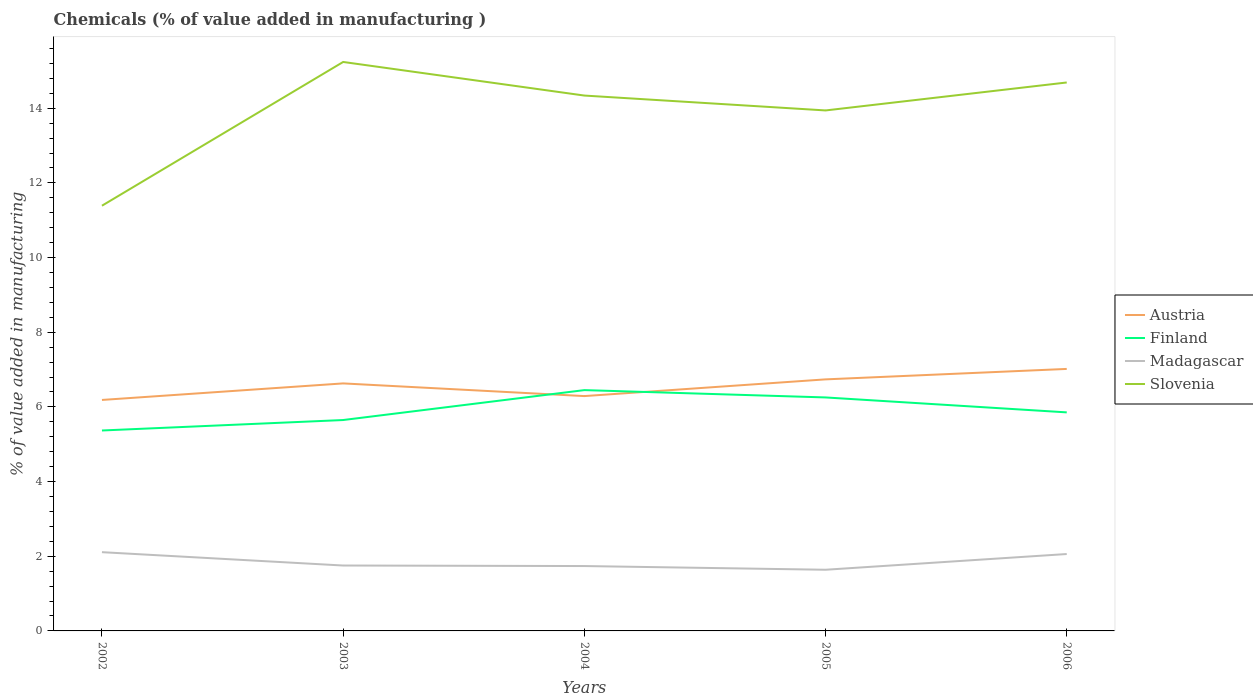How many different coloured lines are there?
Keep it short and to the point. 4. Does the line corresponding to Finland intersect with the line corresponding to Madagascar?
Your answer should be compact. No. Across all years, what is the maximum value added in manufacturing chemicals in Slovenia?
Provide a short and direct response. 11.39. In which year was the value added in manufacturing chemicals in Finland maximum?
Give a very brief answer. 2002. What is the total value added in manufacturing chemicals in Slovenia in the graph?
Offer a terse response. -2.95. What is the difference between the highest and the second highest value added in manufacturing chemicals in Finland?
Your response must be concise. 1.08. What is the difference between the highest and the lowest value added in manufacturing chemicals in Finland?
Give a very brief answer. 2. How many years are there in the graph?
Your answer should be very brief. 5. Are the values on the major ticks of Y-axis written in scientific E-notation?
Offer a terse response. No. How many legend labels are there?
Ensure brevity in your answer.  4. How are the legend labels stacked?
Provide a short and direct response. Vertical. What is the title of the graph?
Your answer should be very brief. Chemicals (% of value added in manufacturing ). What is the label or title of the Y-axis?
Keep it short and to the point. % of value added in manufacturing. What is the % of value added in manufacturing of Austria in 2002?
Offer a very short reply. 6.19. What is the % of value added in manufacturing of Finland in 2002?
Provide a succinct answer. 5.37. What is the % of value added in manufacturing of Madagascar in 2002?
Give a very brief answer. 2.11. What is the % of value added in manufacturing of Slovenia in 2002?
Your answer should be very brief. 11.39. What is the % of value added in manufacturing in Austria in 2003?
Keep it short and to the point. 6.63. What is the % of value added in manufacturing of Finland in 2003?
Your response must be concise. 5.65. What is the % of value added in manufacturing in Madagascar in 2003?
Your response must be concise. 1.75. What is the % of value added in manufacturing in Slovenia in 2003?
Give a very brief answer. 15.24. What is the % of value added in manufacturing in Austria in 2004?
Provide a short and direct response. 6.29. What is the % of value added in manufacturing of Finland in 2004?
Your answer should be very brief. 6.45. What is the % of value added in manufacturing of Madagascar in 2004?
Your answer should be compact. 1.74. What is the % of value added in manufacturing in Slovenia in 2004?
Ensure brevity in your answer.  14.34. What is the % of value added in manufacturing in Austria in 2005?
Your answer should be very brief. 6.74. What is the % of value added in manufacturing in Finland in 2005?
Offer a terse response. 6.25. What is the % of value added in manufacturing of Madagascar in 2005?
Offer a terse response. 1.64. What is the % of value added in manufacturing in Slovenia in 2005?
Offer a terse response. 13.94. What is the % of value added in manufacturing of Austria in 2006?
Your answer should be very brief. 7.02. What is the % of value added in manufacturing in Finland in 2006?
Provide a succinct answer. 5.85. What is the % of value added in manufacturing of Madagascar in 2006?
Ensure brevity in your answer.  2.06. What is the % of value added in manufacturing of Slovenia in 2006?
Provide a succinct answer. 14.69. Across all years, what is the maximum % of value added in manufacturing in Austria?
Offer a very short reply. 7.02. Across all years, what is the maximum % of value added in manufacturing in Finland?
Your answer should be compact. 6.45. Across all years, what is the maximum % of value added in manufacturing in Madagascar?
Your answer should be compact. 2.11. Across all years, what is the maximum % of value added in manufacturing in Slovenia?
Provide a short and direct response. 15.24. Across all years, what is the minimum % of value added in manufacturing of Austria?
Keep it short and to the point. 6.19. Across all years, what is the minimum % of value added in manufacturing in Finland?
Offer a terse response. 5.37. Across all years, what is the minimum % of value added in manufacturing of Madagascar?
Your response must be concise. 1.64. Across all years, what is the minimum % of value added in manufacturing in Slovenia?
Your response must be concise. 11.39. What is the total % of value added in manufacturing of Austria in the graph?
Give a very brief answer. 32.86. What is the total % of value added in manufacturing in Finland in the graph?
Give a very brief answer. 29.57. What is the total % of value added in manufacturing in Madagascar in the graph?
Keep it short and to the point. 9.3. What is the total % of value added in manufacturing in Slovenia in the graph?
Provide a succinct answer. 69.6. What is the difference between the % of value added in manufacturing of Austria in 2002 and that in 2003?
Provide a succinct answer. -0.44. What is the difference between the % of value added in manufacturing in Finland in 2002 and that in 2003?
Your response must be concise. -0.28. What is the difference between the % of value added in manufacturing of Madagascar in 2002 and that in 2003?
Make the answer very short. 0.36. What is the difference between the % of value added in manufacturing of Slovenia in 2002 and that in 2003?
Keep it short and to the point. -3.85. What is the difference between the % of value added in manufacturing in Austria in 2002 and that in 2004?
Give a very brief answer. -0.1. What is the difference between the % of value added in manufacturing of Finland in 2002 and that in 2004?
Keep it short and to the point. -1.08. What is the difference between the % of value added in manufacturing in Madagascar in 2002 and that in 2004?
Provide a succinct answer. 0.37. What is the difference between the % of value added in manufacturing of Slovenia in 2002 and that in 2004?
Offer a very short reply. -2.95. What is the difference between the % of value added in manufacturing in Austria in 2002 and that in 2005?
Your answer should be compact. -0.55. What is the difference between the % of value added in manufacturing of Finland in 2002 and that in 2005?
Ensure brevity in your answer.  -0.89. What is the difference between the % of value added in manufacturing of Madagascar in 2002 and that in 2005?
Your response must be concise. 0.47. What is the difference between the % of value added in manufacturing in Slovenia in 2002 and that in 2005?
Your response must be concise. -2.55. What is the difference between the % of value added in manufacturing in Austria in 2002 and that in 2006?
Provide a short and direct response. -0.83. What is the difference between the % of value added in manufacturing of Finland in 2002 and that in 2006?
Provide a short and direct response. -0.49. What is the difference between the % of value added in manufacturing in Madagascar in 2002 and that in 2006?
Your answer should be very brief. 0.05. What is the difference between the % of value added in manufacturing in Slovenia in 2002 and that in 2006?
Make the answer very short. -3.3. What is the difference between the % of value added in manufacturing of Austria in 2003 and that in 2004?
Your response must be concise. 0.34. What is the difference between the % of value added in manufacturing in Finland in 2003 and that in 2004?
Your answer should be compact. -0.8. What is the difference between the % of value added in manufacturing in Madagascar in 2003 and that in 2004?
Offer a very short reply. 0.01. What is the difference between the % of value added in manufacturing in Slovenia in 2003 and that in 2004?
Your answer should be very brief. 0.9. What is the difference between the % of value added in manufacturing in Austria in 2003 and that in 2005?
Make the answer very short. -0.11. What is the difference between the % of value added in manufacturing in Finland in 2003 and that in 2005?
Give a very brief answer. -0.6. What is the difference between the % of value added in manufacturing in Madagascar in 2003 and that in 2005?
Your answer should be compact. 0.11. What is the difference between the % of value added in manufacturing in Slovenia in 2003 and that in 2005?
Your answer should be very brief. 1.3. What is the difference between the % of value added in manufacturing in Austria in 2003 and that in 2006?
Keep it short and to the point. -0.39. What is the difference between the % of value added in manufacturing in Finland in 2003 and that in 2006?
Your answer should be very brief. -0.2. What is the difference between the % of value added in manufacturing in Madagascar in 2003 and that in 2006?
Keep it short and to the point. -0.31. What is the difference between the % of value added in manufacturing of Slovenia in 2003 and that in 2006?
Give a very brief answer. 0.55. What is the difference between the % of value added in manufacturing of Austria in 2004 and that in 2005?
Offer a very short reply. -0.45. What is the difference between the % of value added in manufacturing in Finland in 2004 and that in 2005?
Make the answer very short. 0.2. What is the difference between the % of value added in manufacturing in Madagascar in 2004 and that in 2005?
Give a very brief answer. 0.1. What is the difference between the % of value added in manufacturing in Slovenia in 2004 and that in 2005?
Your response must be concise. 0.4. What is the difference between the % of value added in manufacturing of Austria in 2004 and that in 2006?
Make the answer very short. -0.73. What is the difference between the % of value added in manufacturing in Finland in 2004 and that in 2006?
Give a very brief answer. 0.6. What is the difference between the % of value added in manufacturing of Madagascar in 2004 and that in 2006?
Make the answer very short. -0.32. What is the difference between the % of value added in manufacturing in Slovenia in 2004 and that in 2006?
Make the answer very short. -0.35. What is the difference between the % of value added in manufacturing of Austria in 2005 and that in 2006?
Provide a short and direct response. -0.28. What is the difference between the % of value added in manufacturing of Finland in 2005 and that in 2006?
Give a very brief answer. 0.4. What is the difference between the % of value added in manufacturing of Madagascar in 2005 and that in 2006?
Provide a succinct answer. -0.42. What is the difference between the % of value added in manufacturing in Slovenia in 2005 and that in 2006?
Offer a terse response. -0.75. What is the difference between the % of value added in manufacturing in Austria in 2002 and the % of value added in manufacturing in Finland in 2003?
Your answer should be very brief. 0.54. What is the difference between the % of value added in manufacturing of Austria in 2002 and the % of value added in manufacturing of Madagascar in 2003?
Keep it short and to the point. 4.43. What is the difference between the % of value added in manufacturing of Austria in 2002 and the % of value added in manufacturing of Slovenia in 2003?
Provide a succinct answer. -9.05. What is the difference between the % of value added in manufacturing of Finland in 2002 and the % of value added in manufacturing of Madagascar in 2003?
Provide a succinct answer. 3.62. What is the difference between the % of value added in manufacturing in Finland in 2002 and the % of value added in manufacturing in Slovenia in 2003?
Keep it short and to the point. -9.87. What is the difference between the % of value added in manufacturing in Madagascar in 2002 and the % of value added in manufacturing in Slovenia in 2003?
Give a very brief answer. -13.13. What is the difference between the % of value added in manufacturing of Austria in 2002 and the % of value added in manufacturing of Finland in 2004?
Offer a terse response. -0.26. What is the difference between the % of value added in manufacturing of Austria in 2002 and the % of value added in manufacturing of Madagascar in 2004?
Provide a short and direct response. 4.45. What is the difference between the % of value added in manufacturing of Austria in 2002 and the % of value added in manufacturing of Slovenia in 2004?
Ensure brevity in your answer.  -8.15. What is the difference between the % of value added in manufacturing of Finland in 2002 and the % of value added in manufacturing of Madagascar in 2004?
Provide a succinct answer. 3.63. What is the difference between the % of value added in manufacturing of Finland in 2002 and the % of value added in manufacturing of Slovenia in 2004?
Provide a short and direct response. -8.97. What is the difference between the % of value added in manufacturing in Madagascar in 2002 and the % of value added in manufacturing in Slovenia in 2004?
Offer a very short reply. -12.23. What is the difference between the % of value added in manufacturing of Austria in 2002 and the % of value added in manufacturing of Finland in 2005?
Provide a succinct answer. -0.07. What is the difference between the % of value added in manufacturing of Austria in 2002 and the % of value added in manufacturing of Madagascar in 2005?
Your answer should be compact. 4.55. What is the difference between the % of value added in manufacturing of Austria in 2002 and the % of value added in manufacturing of Slovenia in 2005?
Your answer should be compact. -7.75. What is the difference between the % of value added in manufacturing of Finland in 2002 and the % of value added in manufacturing of Madagascar in 2005?
Make the answer very short. 3.73. What is the difference between the % of value added in manufacturing of Finland in 2002 and the % of value added in manufacturing of Slovenia in 2005?
Your response must be concise. -8.57. What is the difference between the % of value added in manufacturing in Madagascar in 2002 and the % of value added in manufacturing in Slovenia in 2005?
Ensure brevity in your answer.  -11.83. What is the difference between the % of value added in manufacturing in Austria in 2002 and the % of value added in manufacturing in Finland in 2006?
Provide a short and direct response. 0.33. What is the difference between the % of value added in manufacturing in Austria in 2002 and the % of value added in manufacturing in Madagascar in 2006?
Provide a succinct answer. 4.13. What is the difference between the % of value added in manufacturing in Austria in 2002 and the % of value added in manufacturing in Slovenia in 2006?
Keep it short and to the point. -8.5. What is the difference between the % of value added in manufacturing in Finland in 2002 and the % of value added in manufacturing in Madagascar in 2006?
Offer a very short reply. 3.31. What is the difference between the % of value added in manufacturing in Finland in 2002 and the % of value added in manufacturing in Slovenia in 2006?
Make the answer very short. -9.32. What is the difference between the % of value added in manufacturing in Madagascar in 2002 and the % of value added in manufacturing in Slovenia in 2006?
Provide a short and direct response. -12.58. What is the difference between the % of value added in manufacturing of Austria in 2003 and the % of value added in manufacturing of Finland in 2004?
Your answer should be compact. 0.18. What is the difference between the % of value added in manufacturing of Austria in 2003 and the % of value added in manufacturing of Madagascar in 2004?
Offer a terse response. 4.89. What is the difference between the % of value added in manufacturing of Austria in 2003 and the % of value added in manufacturing of Slovenia in 2004?
Provide a short and direct response. -7.71. What is the difference between the % of value added in manufacturing of Finland in 2003 and the % of value added in manufacturing of Madagascar in 2004?
Give a very brief answer. 3.91. What is the difference between the % of value added in manufacturing in Finland in 2003 and the % of value added in manufacturing in Slovenia in 2004?
Offer a terse response. -8.69. What is the difference between the % of value added in manufacturing in Madagascar in 2003 and the % of value added in manufacturing in Slovenia in 2004?
Give a very brief answer. -12.59. What is the difference between the % of value added in manufacturing of Austria in 2003 and the % of value added in manufacturing of Finland in 2005?
Offer a very short reply. 0.38. What is the difference between the % of value added in manufacturing of Austria in 2003 and the % of value added in manufacturing of Madagascar in 2005?
Make the answer very short. 4.99. What is the difference between the % of value added in manufacturing of Austria in 2003 and the % of value added in manufacturing of Slovenia in 2005?
Your response must be concise. -7.31. What is the difference between the % of value added in manufacturing of Finland in 2003 and the % of value added in manufacturing of Madagascar in 2005?
Offer a very short reply. 4.01. What is the difference between the % of value added in manufacturing of Finland in 2003 and the % of value added in manufacturing of Slovenia in 2005?
Your response must be concise. -8.29. What is the difference between the % of value added in manufacturing of Madagascar in 2003 and the % of value added in manufacturing of Slovenia in 2005?
Give a very brief answer. -12.19. What is the difference between the % of value added in manufacturing in Austria in 2003 and the % of value added in manufacturing in Finland in 2006?
Keep it short and to the point. 0.78. What is the difference between the % of value added in manufacturing of Austria in 2003 and the % of value added in manufacturing of Madagascar in 2006?
Offer a terse response. 4.57. What is the difference between the % of value added in manufacturing of Austria in 2003 and the % of value added in manufacturing of Slovenia in 2006?
Make the answer very short. -8.06. What is the difference between the % of value added in manufacturing in Finland in 2003 and the % of value added in manufacturing in Madagascar in 2006?
Your answer should be compact. 3.59. What is the difference between the % of value added in manufacturing in Finland in 2003 and the % of value added in manufacturing in Slovenia in 2006?
Your answer should be compact. -9.04. What is the difference between the % of value added in manufacturing of Madagascar in 2003 and the % of value added in manufacturing of Slovenia in 2006?
Offer a very short reply. -12.94. What is the difference between the % of value added in manufacturing of Austria in 2004 and the % of value added in manufacturing of Finland in 2005?
Make the answer very short. 0.04. What is the difference between the % of value added in manufacturing in Austria in 2004 and the % of value added in manufacturing in Madagascar in 2005?
Provide a succinct answer. 4.65. What is the difference between the % of value added in manufacturing of Austria in 2004 and the % of value added in manufacturing of Slovenia in 2005?
Your response must be concise. -7.65. What is the difference between the % of value added in manufacturing in Finland in 2004 and the % of value added in manufacturing in Madagascar in 2005?
Provide a short and direct response. 4.81. What is the difference between the % of value added in manufacturing in Finland in 2004 and the % of value added in manufacturing in Slovenia in 2005?
Your response must be concise. -7.49. What is the difference between the % of value added in manufacturing in Madagascar in 2004 and the % of value added in manufacturing in Slovenia in 2005?
Offer a terse response. -12.2. What is the difference between the % of value added in manufacturing in Austria in 2004 and the % of value added in manufacturing in Finland in 2006?
Offer a terse response. 0.44. What is the difference between the % of value added in manufacturing of Austria in 2004 and the % of value added in manufacturing of Madagascar in 2006?
Give a very brief answer. 4.23. What is the difference between the % of value added in manufacturing of Austria in 2004 and the % of value added in manufacturing of Slovenia in 2006?
Your answer should be compact. -8.4. What is the difference between the % of value added in manufacturing of Finland in 2004 and the % of value added in manufacturing of Madagascar in 2006?
Give a very brief answer. 4.39. What is the difference between the % of value added in manufacturing of Finland in 2004 and the % of value added in manufacturing of Slovenia in 2006?
Provide a short and direct response. -8.24. What is the difference between the % of value added in manufacturing of Madagascar in 2004 and the % of value added in manufacturing of Slovenia in 2006?
Provide a short and direct response. -12.95. What is the difference between the % of value added in manufacturing in Austria in 2005 and the % of value added in manufacturing in Finland in 2006?
Offer a terse response. 0.88. What is the difference between the % of value added in manufacturing in Austria in 2005 and the % of value added in manufacturing in Madagascar in 2006?
Keep it short and to the point. 4.68. What is the difference between the % of value added in manufacturing in Austria in 2005 and the % of value added in manufacturing in Slovenia in 2006?
Give a very brief answer. -7.95. What is the difference between the % of value added in manufacturing of Finland in 2005 and the % of value added in manufacturing of Madagascar in 2006?
Provide a short and direct response. 4.19. What is the difference between the % of value added in manufacturing of Finland in 2005 and the % of value added in manufacturing of Slovenia in 2006?
Offer a very short reply. -8.44. What is the difference between the % of value added in manufacturing of Madagascar in 2005 and the % of value added in manufacturing of Slovenia in 2006?
Give a very brief answer. -13.05. What is the average % of value added in manufacturing in Austria per year?
Make the answer very short. 6.57. What is the average % of value added in manufacturing in Finland per year?
Your answer should be compact. 5.92. What is the average % of value added in manufacturing of Madagascar per year?
Offer a very short reply. 1.86. What is the average % of value added in manufacturing of Slovenia per year?
Give a very brief answer. 13.92. In the year 2002, what is the difference between the % of value added in manufacturing of Austria and % of value added in manufacturing of Finland?
Give a very brief answer. 0.82. In the year 2002, what is the difference between the % of value added in manufacturing in Austria and % of value added in manufacturing in Madagascar?
Offer a very short reply. 4.08. In the year 2002, what is the difference between the % of value added in manufacturing of Austria and % of value added in manufacturing of Slovenia?
Offer a terse response. -5.2. In the year 2002, what is the difference between the % of value added in manufacturing of Finland and % of value added in manufacturing of Madagascar?
Ensure brevity in your answer.  3.26. In the year 2002, what is the difference between the % of value added in manufacturing of Finland and % of value added in manufacturing of Slovenia?
Provide a short and direct response. -6.02. In the year 2002, what is the difference between the % of value added in manufacturing of Madagascar and % of value added in manufacturing of Slovenia?
Make the answer very short. -9.28. In the year 2003, what is the difference between the % of value added in manufacturing in Austria and % of value added in manufacturing in Finland?
Provide a short and direct response. 0.98. In the year 2003, what is the difference between the % of value added in manufacturing in Austria and % of value added in manufacturing in Madagascar?
Keep it short and to the point. 4.88. In the year 2003, what is the difference between the % of value added in manufacturing in Austria and % of value added in manufacturing in Slovenia?
Make the answer very short. -8.61. In the year 2003, what is the difference between the % of value added in manufacturing in Finland and % of value added in manufacturing in Madagascar?
Offer a terse response. 3.9. In the year 2003, what is the difference between the % of value added in manufacturing of Finland and % of value added in manufacturing of Slovenia?
Provide a succinct answer. -9.59. In the year 2003, what is the difference between the % of value added in manufacturing in Madagascar and % of value added in manufacturing in Slovenia?
Provide a succinct answer. -13.49. In the year 2004, what is the difference between the % of value added in manufacturing in Austria and % of value added in manufacturing in Finland?
Offer a terse response. -0.16. In the year 2004, what is the difference between the % of value added in manufacturing of Austria and % of value added in manufacturing of Madagascar?
Provide a short and direct response. 4.55. In the year 2004, what is the difference between the % of value added in manufacturing in Austria and % of value added in manufacturing in Slovenia?
Keep it short and to the point. -8.05. In the year 2004, what is the difference between the % of value added in manufacturing of Finland and % of value added in manufacturing of Madagascar?
Make the answer very short. 4.71. In the year 2004, what is the difference between the % of value added in manufacturing in Finland and % of value added in manufacturing in Slovenia?
Your response must be concise. -7.89. In the year 2004, what is the difference between the % of value added in manufacturing of Madagascar and % of value added in manufacturing of Slovenia?
Your answer should be very brief. -12.6. In the year 2005, what is the difference between the % of value added in manufacturing in Austria and % of value added in manufacturing in Finland?
Keep it short and to the point. 0.48. In the year 2005, what is the difference between the % of value added in manufacturing of Austria and % of value added in manufacturing of Madagascar?
Offer a terse response. 5.1. In the year 2005, what is the difference between the % of value added in manufacturing of Austria and % of value added in manufacturing of Slovenia?
Keep it short and to the point. -7.2. In the year 2005, what is the difference between the % of value added in manufacturing of Finland and % of value added in manufacturing of Madagascar?
Keep it short and to the point. 4.62. In the year 2005, what is the difference between the % of value added in manufacturing of Finland and % of value added in manufacturing of Slovenia?
Offer a very short reply. -7.69. In the year 2005, what is the difference between the % of value added in manufacturing in Madagascar and % of value added in manufacturing in Slovenia?
Your answer should be compact. -12.3. In the year 2006, what is the difference between the % of value added in manufacturing of Austria and % of value added in manufacturing of Finland?
Make the answer very short. 1.16. In the year 2006, what is the difference between the % of value added in manufacturing in Austria and % of value added in manufacturing in Madagascar?
Provide a short and direct response. 4.96. In the year 2006, what is the difference between the % of value added in manufacturing of Austria and % of value added in manufacturing of Slovenia?
Your answer should be very brief. -7.67. In the year 2006, what is the difference between the % of value added in manufacturing in Finland and % of value added in manufacturing in Madagascar?
Your response must be concise. 3.79. In the year 2006, what is the difference between the % of value added in manufacturing of Finland and % of value added in manufacturing of Slovenia?
Ensure brevity in your answer.  -8.84. In the year 2006, what is the difference between the % of value added in manufacturing in Madagascar and % of value added in manufacturing in Slovenia?
Offer a very short reply. -12.63. What is the ratio of the % of value added in manufacturing of Austria in 2002 to that in 2003?
Give a very brief answer. 0.93. What is the ratio of the % of value added in manufacturing in Finland in 2002 to that in 2003?
Your answer should be compact. 0.95. What is the ratio of the % of value added in manufacturing of Madagascar in 2002 to that in 2003?
Your answer should be very brief. 1.2. What is the ratio of the % of value added in manufacturing of Slovenia in 2002 to that in 2003?
Offer a very short reply. 0.75. What is the ratio of the % of value added in manufacturing in Austria in 2002 to that in 2004?
Make the answer very short. 0.98. What is the ratio of the % of value added in manufacturing of Finland in 2002 to that in 2004?
Offer a terse response. 0.83. What is the ratio of the % of value added in manufacturing in Madagascar in 2002 to that in 2004?
Offer a very short reply. 1.21. What is the ratio of the % of value added in manufacturing of Slovenia in 2002 to that in 2004?
Your response must be concise. 0.79. What is the ratio of the % of value added in manufacturing of Austria in 2002 to that in 2005?
Your response must be concise. 0.92. What is the ratio of the % of value added in manufacturing of Finland in 2002 to that in 2005?
Offer a very short reply. 0.86. What is the ratio of the % of value added in manufacturing of Madagascar in 2002 to that in 2005?
Keep it short and to the point. 1.29. What is the ratio of the % of value added in manufacturing of Slovenia in 2002 to that in 2005?
Keep it short and to the point. 0.82. What is the ratio of the % of value added in manufacturing in Austria in 2002 to that in 2006?
Give a very brief answer. 0.88. What is the ratio of the % of value added in manufacturing of Finland in 2002 to that in 2006?
Keep it short and to the point. 0.92. What is the ratio of the % of value added in manufacturing of Madagascar in 2002 to that in 2006?
Provide a succinct answer. 1.02. What is the ratio of the % of value added in manufacturing of Slovenia in 2002 to that in 2006?
Ensure brevity in your answer.  0.78. What is the ratio of the % of value added in manufacturing of Austria in 2003 to that in 2004?
Keep it short and to the point. 1.05. What is the ratio of the % of value added in manufacturing in Finland in 2003 to that in 2004?
Provide a short and direct response. 0.88. What is the ratio of the % of value added in manufacturing in Madagascar in 2003 to that in 2004?
Provide a short and direct response. 1.01. What is the ratio of the % of value added in manufacturing of Slovenia in 2003 to that in 2004?
Provide a succinct answer. 1.06. What is the ratio of the % of value added in manufacturing in Austria in 2003 to that in 2005?
Your answer should be very brief. 0.98. What is the ratio of the % of value added in manufacturing in Finland in 2003 to that in 2005?
Your answer should be compact. 0.9. What is the ratio of the % of value added in manufacturing in Madagascar in 2003 to that in 2005?
Offer a very short reply. 1.07. What is the ratio of the % of value added in manufacturing in Slovenia in 2003 to that in 2005?
Make the answer very short. 1.09. What is the ratio of the % of value added in manufacturing in Austria in 2003 to that in 2006?
Give a very brief answer. 0.94. What is the ratio of the % of value added in manufacturing in Finland in 2003 to that in 2006?
Keep it short and to the point. 0.96. What is the ratio of the % of value added in manufacturing in Madagascar in 2003 to that in 2006?
Provide a succinct answer. 0.85. What is the ratio of the % of value added in manufacturing of Slovenia in 2003 to that in 2006?
Ensure brevity in your answer.  1.04. What is the ratio of the % of value added in manufacturing of Austria in 2004 to that in 2005?
Keep it short and to the point. 0.93. What is the ratio of the % of value added in manufacturing of Finland in 2004 to that in 2005?
Your answer should be compact. 1.03. What is the ratio of the % of value added in manufacturing of Madagascar in 2004 to that in 2005?
Offer a very short reply. 1.06. What is the ratio of the % of value added in manufacturing in Slovenia in 2004 to that in 2005?
Offer a terse response. 1.03. What is the ratio of the % of value added in manufacturing of Austria in 2004 to that in 2006?
Make the answer very short. 0.9. What is the ratio of the % of value added in manufacturing of Finland in 2004 to that in 2006?
Your response must be concise. 1.1. What is the ratio of the % of value added in manufacturing in Madagascar in 2004 to that in 2006?
Keep it short and to the point. 0.84. What is the ratio of the % of value added in manufacturing of Slovenia in 2004 to that in 2006?
Your response must be concise. 0.98. What is the ratio of the % of value added in manufacturing in Austria in 2005 to that in 2006?
Keep it short and to the point. 0.96. What is the ratio of the % of value added in manufacturing of Finland in 2005 to that in 2006?
Offer a very short reply. 1.07. What is the ratio of the % of value added in manufacturing of Madagascar in 2005 to that in 2006?
Offer a very short reply. 0.8. What is the ratio of the % of value added in manufacturing in Slovenia in 2005 to that in 2006?
Offer a very short reply. 0.95. What is the difference between the highest and the second highest % of value added in manufacturing in Austria?
Provide a short and direct response. 0.28. What is the difference between the highest and the second highest % of value added in manufacturing of Finland?
Make the answer very short. 0.2. What is the difference between the highest and the second highest % of value added in manufacturing in Madagascar?
Your answer should be compact. 0.05. What is the difference between the highest and the second highest % of value added in manufacturing in Slovenia?
Offer a terse response. 0.55. What is the difference between the highest and the lowest % of value added in manufacturing of Austria?
Your answer should be compact. 0.83. What is the difference between the highest and the lowest % of value added in manufacturing of Finland?
Offer a very short reply. 1.08. What is the difference between the highest and the lowest % of value added in manufacturing in Madagascar?
Give a very brief answer. 0.47. What is the difference between the highest and the lowest % of value added in manufacturing of Slovenia?
Make the answer very short. 3.85. 